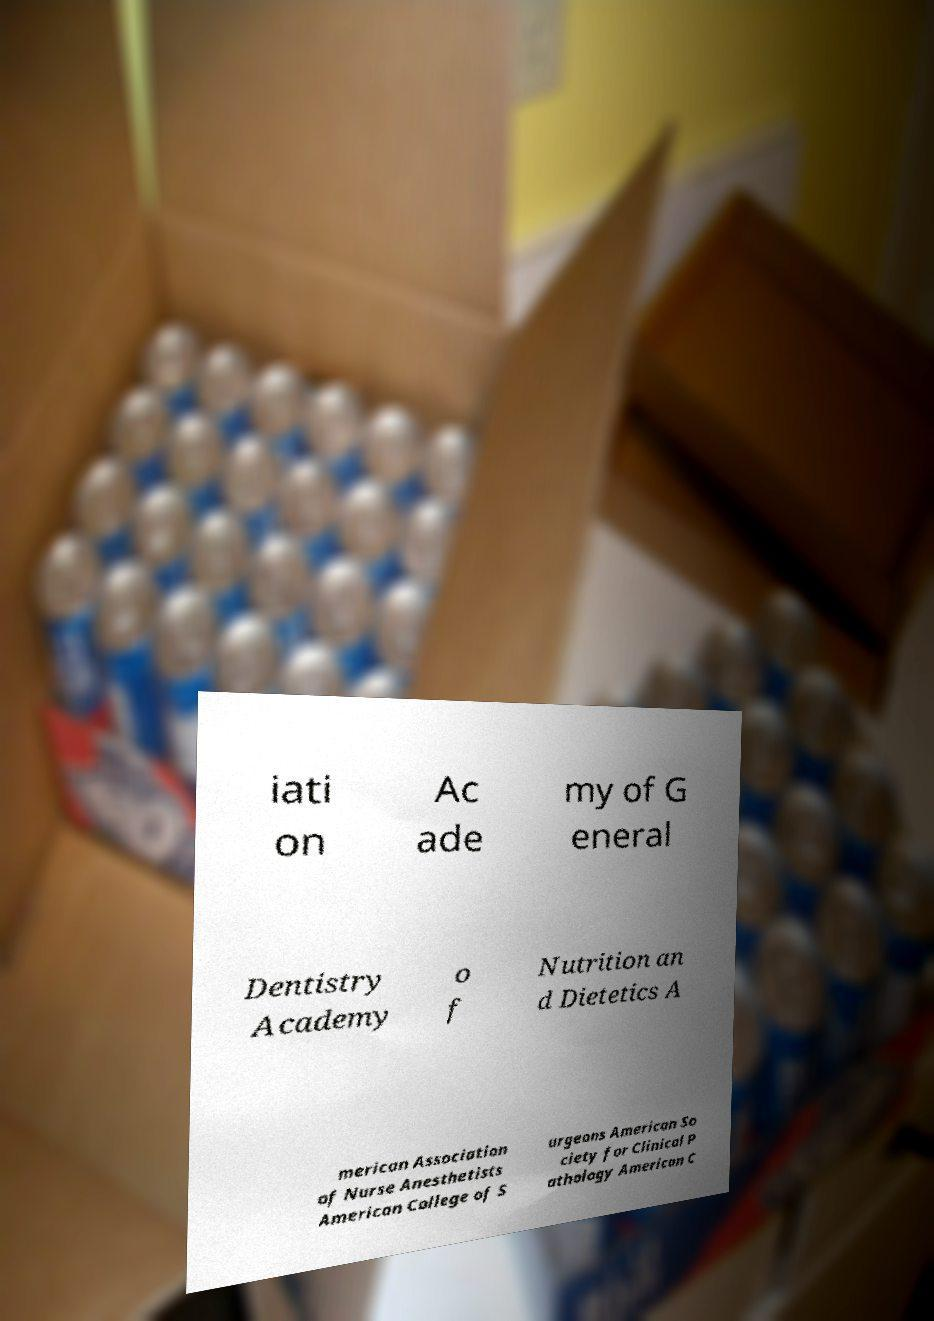Please read and relay the text visible in this image. What does it say? iati on Ac ade my of G eneral Dentistry Academy o f Nutrition an d Dietetics A merican Association of Nurse Anesthetists American College of S urgeons American So ciety for Clinical P athology American C 